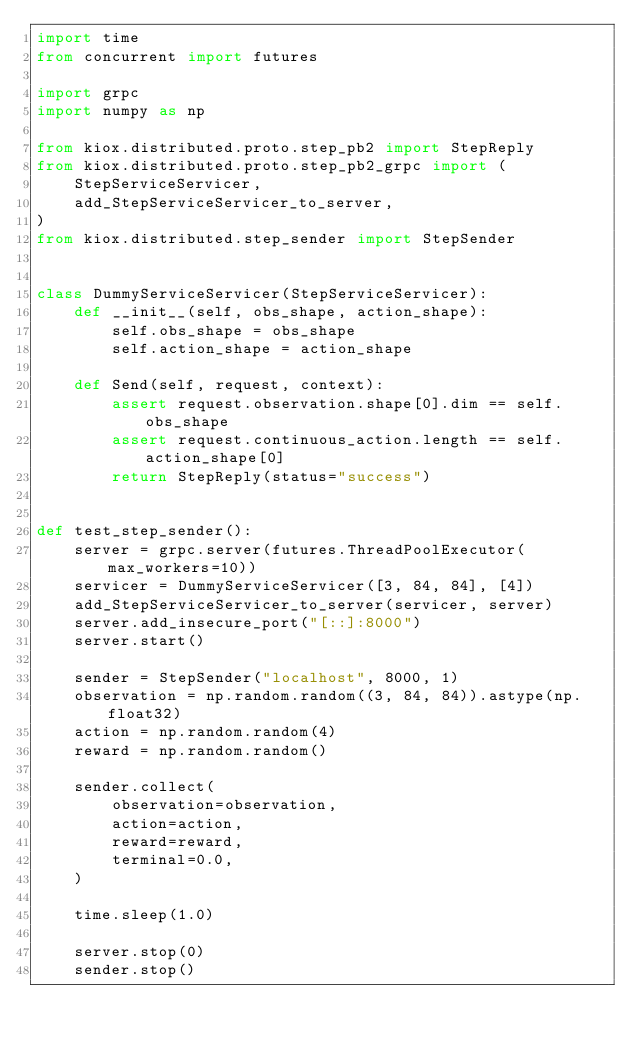<code> <loc_0><loc_0><loc_500><loc_500><_Python_>import time
from concurrent import futures

import grpc
import numpy as np

from kiox.distributed.proto.step_pb2 import StepReply
from kiox.distributed.proto.step_pb2_grpc import (
    StepServiceServicer,
    add_StepServiceServicer_to_server,
)
from kiox.distributed.step_sender import StepSender


class DummyServiceServicer(StepServiceServicer):
    def __init__(self, obs_shape, action_shape):
        self.obs_shape = obs_shape
        self.action_shape = action_shape

    def Send(self, request, context):
        assert request.observation.shape[0].dim == self.obs_shape
        assert request.continuous_action.length == self.action_shape[0]
        return StepReply(status="success")


def test_step_sender():
    server = grpc.server(futures.ThreadPoolExecutor(max_workers=10))
    servicer = DummyServiceServicer([3, 84, 84], [4])
    add_StepServiceServicer_to_server(servicer, server)
    server.add_insecure_port("[::]:8000")
    server.start()

    sender = StepSender("localhost", 8000, 1)
    observation = np.random.random((3, 84, 84)).astype(np.float32)
    action = np.random.random(4)
    reward = np.random.random()

    sender.collect(
        observation=observation,
        action=action,
        reward=reward,
        terminal=0.0,
    )

    time.sleep(1.0)

    server.stop(0)
    sender.stop()
</code> 